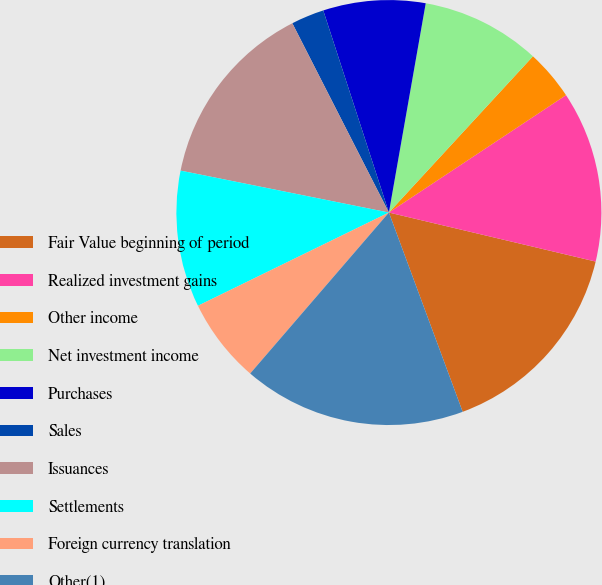Convert chart to OTSL. <chart><loc_0><loc_0><loc_500><loc_500><pie_chart><fcel>Fair Value beginning of period<fcel>Realized investment gains<fcel>Other income<fcel>Net investment income<fcel>Purchases<fcel>Sales<fcel>Issuances<fcel>Settlements<fcel>Foreign currency translation<fcel>Other(1)<nl><fcel>15.65%<fcel>13.02%<fcel>3.83%<fcel>9.08%<fcel>7.77%<fcel>2.51%<fcel>14.33%<fcel>10.39%<fcel>6.45%<fcel>16.96%<nl></chart> 